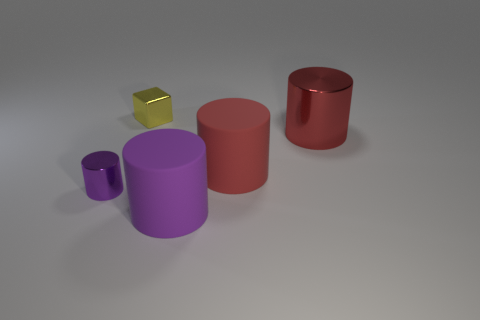Subtract all big cylinders. How many cylinders are left? 1 Subtract all red cylinders. How many cylinders are left? 2 Add 2 large red matte cylinders. How many objects exist? 7 Subtract all cylinders. How many objects are left? 1 Add 5 yellow metallic blocks. How many yellow metallic blocks are left? 6 Add 5 blue shiny cylinders. How many blue shiny cylinders exist? 5 Subtract 0 green balls. How many objects are left? 5 Subtract 1 cylinders. How many cylinders are left? 3 Subtract all brown cubes. Subtract all purple cylinders. How many cubes are left? 1 Subtract all gray cubes. How many red cylinders are left? 2 